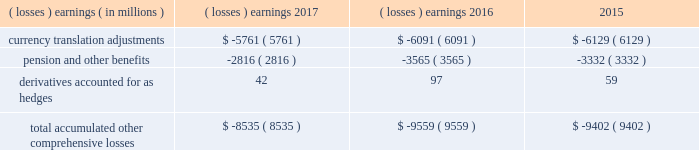Note 17 .
Accumulated other comprehensive losses : pmi's accumulated other comprehensive losses , net of taxes , consisted of the following: .
Reclassifications from other comprehensive earnings the movements in accumulated other comprehensive losses and the related tax impact , for each of the components above , that are due to current period activity and reclassifications to the income statement are shown on the consolidated statements of comprehensive earnings for the years ended december 31 , 2017 , 2016 , and 2015 .
For the years ended december 31 , 2017 , 2016 , and 2015 , $ 2 million , $ ( 5 ) million and $ 1 million of net currency translation adjustment gains/ ( losses ) were transferred from other comprehensive earnings to marketing , administration and research costs in the consolidated statements of earnings , respectively , upon liquidation of subsidiaries .
For additional information , see note 13 .
Benefit plans and note 15 .
Financial instruments for disclosures related to pmi's pension and other benefits and derivative financial instruments .
Note 18 .
Contingencies : tobacco-related litigation legal proceedings covering a wide range of matters are pending or threatened against us , and/or our subsidiaries , and/or our indemnitees in various jurisdictions .
Our indemnitees include distributors , licensees and others that have been named as parties in certain cases and that we have agreed to defend , as well as to pay costs and some or all of judgments , if any , that may be entered against them .
Pursuant to the terms of the distribution agreement between altria group , inc .
( "altria" ) and pmi , pmi will indemnify altria and philip morris usa inc .
( "pm usa" ) , a u.s .
Tobacco subsidiary of altria , for tobacco product claims based in substantial part on products manufactured by pmi or contract manufactured for pmi by pm usa , and pm usa will indemnify pmi for tobacco product claims based in substantial part on products manufactured by pm usa , excluding tobacco products contract manufactured for pmi .
It is possible that there could be adverse developments in pending cases against us and our subsidiaries .
An unfavorable outcome or settlement of pending tobacco-related litigation could encourage the commencement of additional litigation .
Damages claimed in some of the tobacco-related litigation are significant and , in certain cases in brazil , canada and nigeria , range into the billions of u.s .
Dollars .
The variability in pleadings in multiple jurisdictions , together with the actual experience of management in litigating claims , demonstrate that the monetary relief that may be specified in a lawsuit bears little relevance to the ultimate outcome .
Much of the tobacco-related litigation is in its early stages , and litigation is subject to uncertainty .
However , as discussed below , we have to date been largely successful in defending tobacco-related litigation .
We and our subsidiaries record provisions in the consolidated financial statements for pending litigation when we determine that an unfavorable outcome is probable and the amount of the loss can be reasonably estimated .
At the present time , while it is reasonably possible that an unfavorable outcome in a case may occur , after assessing the information available to it ( i ) management has not concluded that it is probable that a loss has been incurred in any of the pending tobacco-related cases ; ( ii ) management is unable to estimate the possible loss or range of loss for any of the pending tobacco-related cases ; and ( iii ) accordingly , no estimated loss has been accrued in the consolidated financial statements for unfavorable outcomes in these cases , if any .
Legal defense costs are expensed as incurred. .
What is the percentage change in currency translation adjustments from 2016 to 2017? 
Computations: ((-5761 - -6091) / -6091)
Answer: -0.05418. 